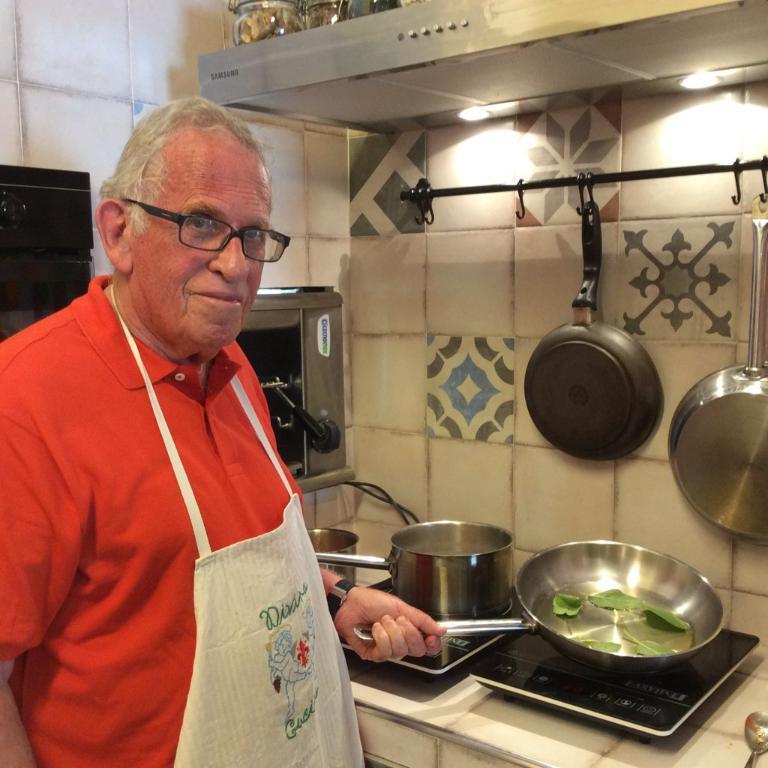Please provide a concise description of this image. As we can see in the image there are tiles, bowls, pans, induction stoves and a person wearing red color t shirt. 